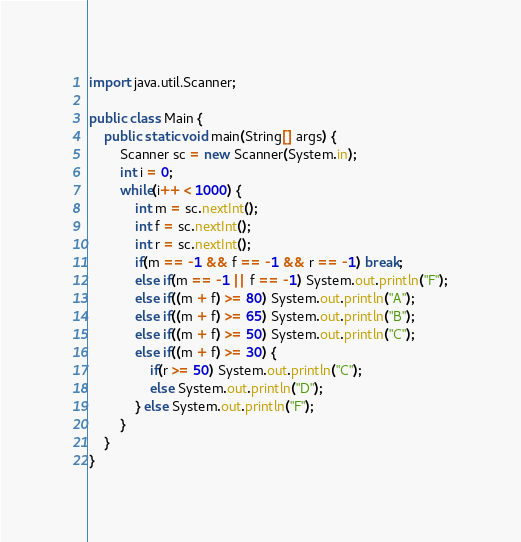Convert code to text. <code><loc_0><loc_0><loc_500><loc_500><_Java_>import java.util.Scanner;

public class Main {
    public static void main(String[] args) {
        Scanner sc = new Scanner(System.in);
        int i = 0;
        while(i++ < 1000) {
            int m = sc.nextInt();
            int f = sc.nextInt();
            int r = sc.nextInt();
            if(m == -1 && f == -1 && r == -1) break;
            else if(m == -1 || f == -1) System.out.println("F");
            else if((m + f) >= 80) System.out.println("A");
            else if((m + f) >= 65) System.out.println("B");
            else if((m + f) >= 50) System.out.println("C");
            else if((m + f) >= 30) {
                if(r >= 50) System.out.println("C");
                else System.out.println("D");
            } else System.out.println("F");
        }
    }
}

</code> 